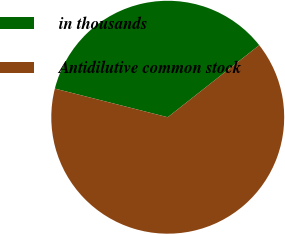<chart> <loc_0><loc_0><loc_500><loc_500><pie_chart><fcel>in thousands<fcel>Antidilutive common stock<nl><fcel>35.43%<fcel>64.57%<nl></chart> 